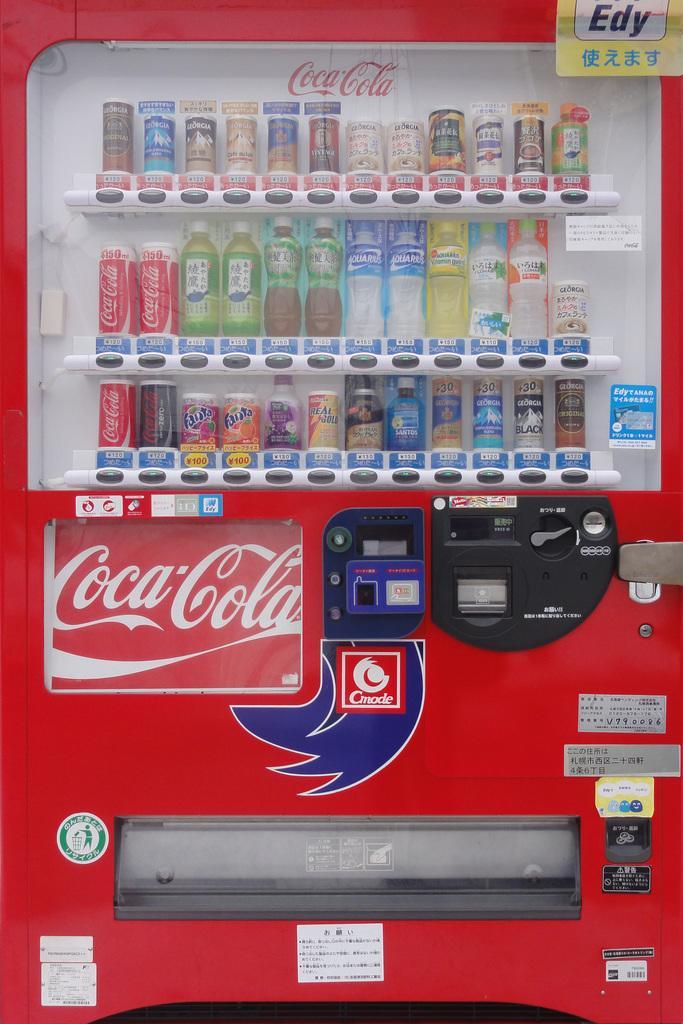Can you describe this image briefly? In this image, we can see a vending machine contains some bottles. 